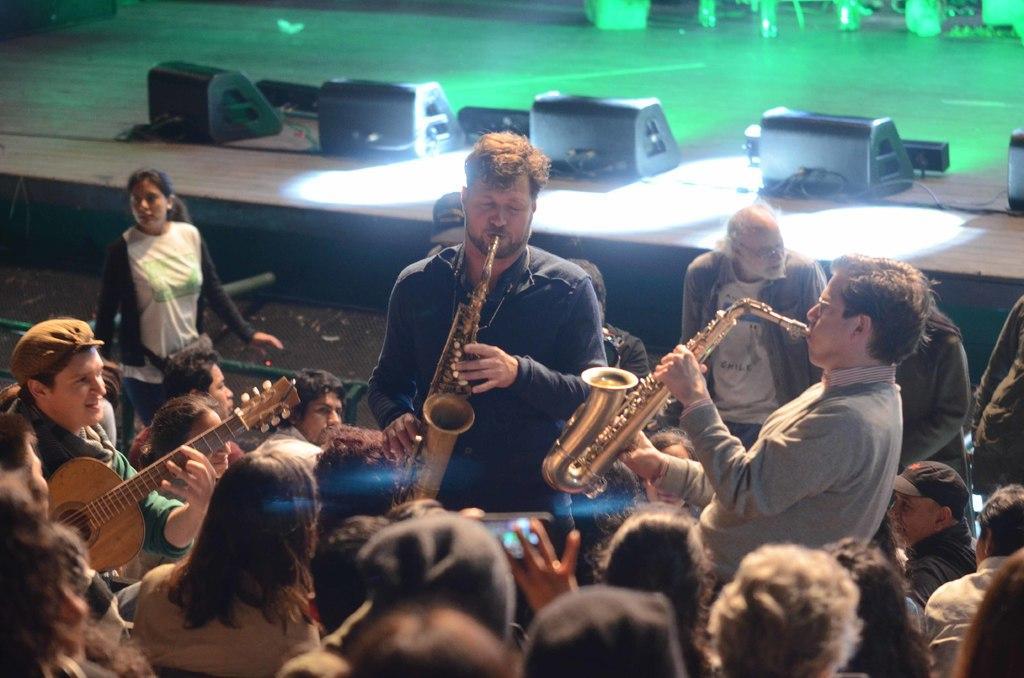Could you give a brief overview of what you see in this image? there are group of people in the picture in which there are playing different musical instruments 